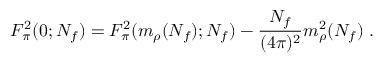Convert formula to latex. <formula><loc_0><loc_0><loc_500><loc_500>F _ { \pi } ^ { 2 } ( 0 ; N _ { f } ) = F _ { \pi } ^ { 2 } ( m _ { \rho } ( N _ { f } ) ; N _ { f } ) - \frac { N _ { f } } { ( 4 \pi ) ^ { 2 } } m _ { \rho } ^ { 2 } ( N _ { f } ) \ .</formula> 